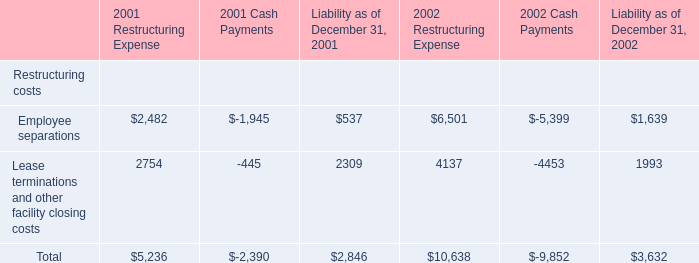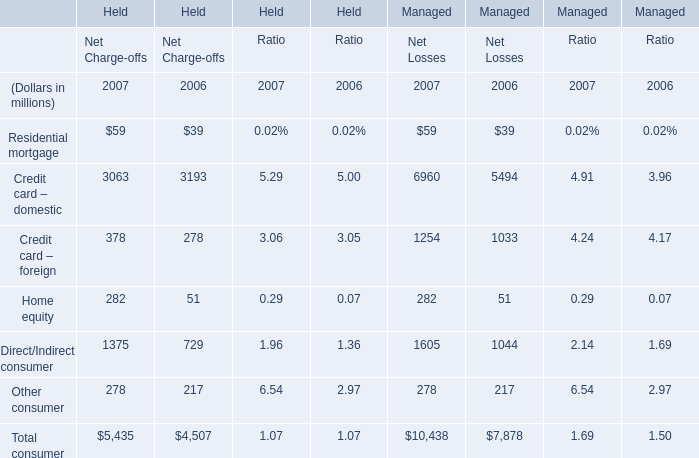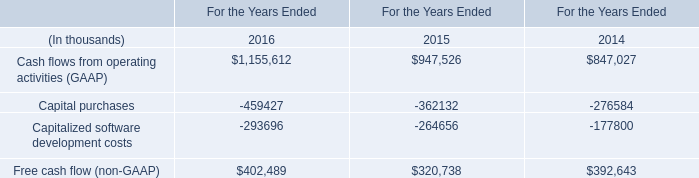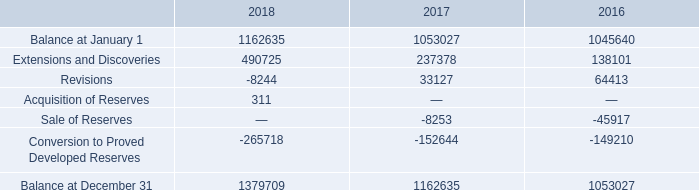What's the average of Total consumer in 2007? (in million) 
Computations: ((5435 + 10438) / 2)
Answer: 7936.5. 